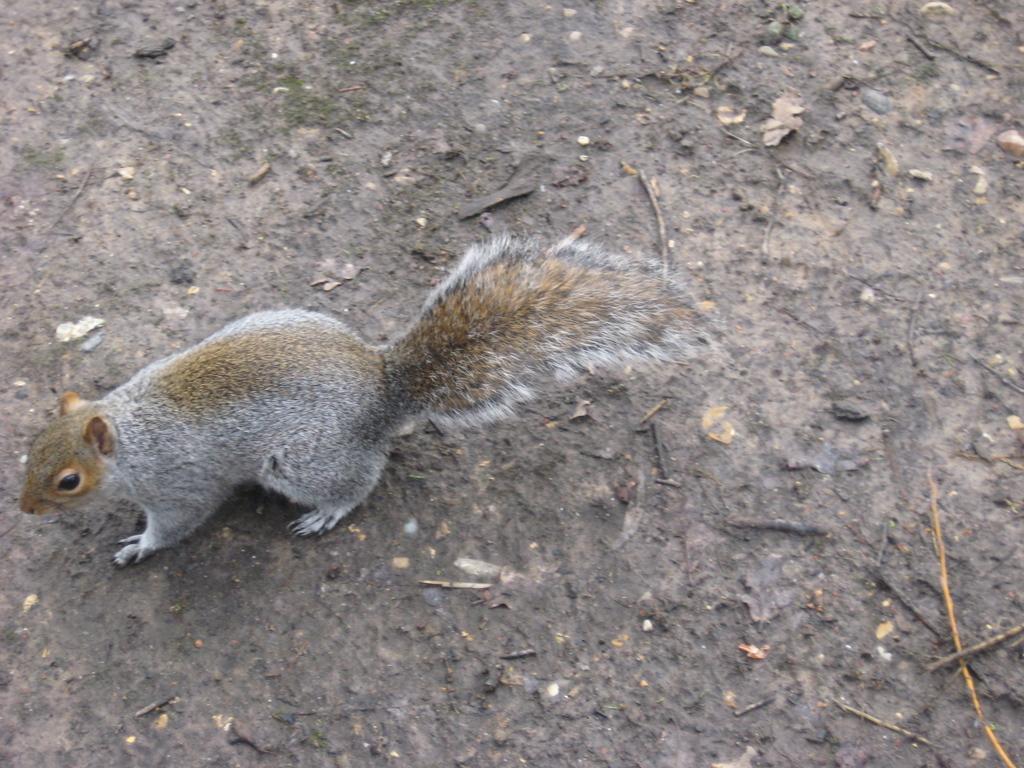Can you describe this image briefly? In this image on the left there is a squirrel. In the middle there is a land. 